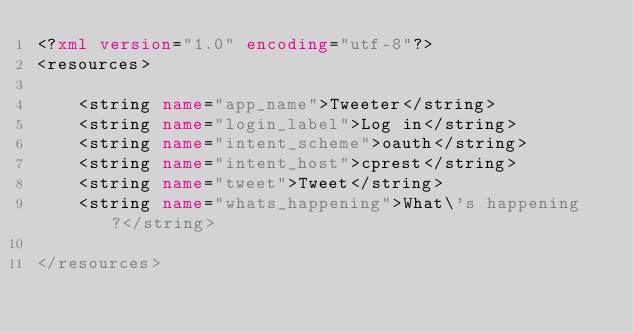Convert code to text. <code><loc_0><loc_0><loc_500><loc_500><_XML_><?xml version="1.0" encoding="utf-8"?>
<resources>

    <string name="app_name">Tweeter</string>
    <string name="login_label">Log in</string>
    <string name="intent_scheme">oauth</string>
    <string name="intent_host">cprest</string>
    <string name="tweet">Tweet</string>
    <string name="whats_happening">What\'s happening?</string>

</resources></code> 